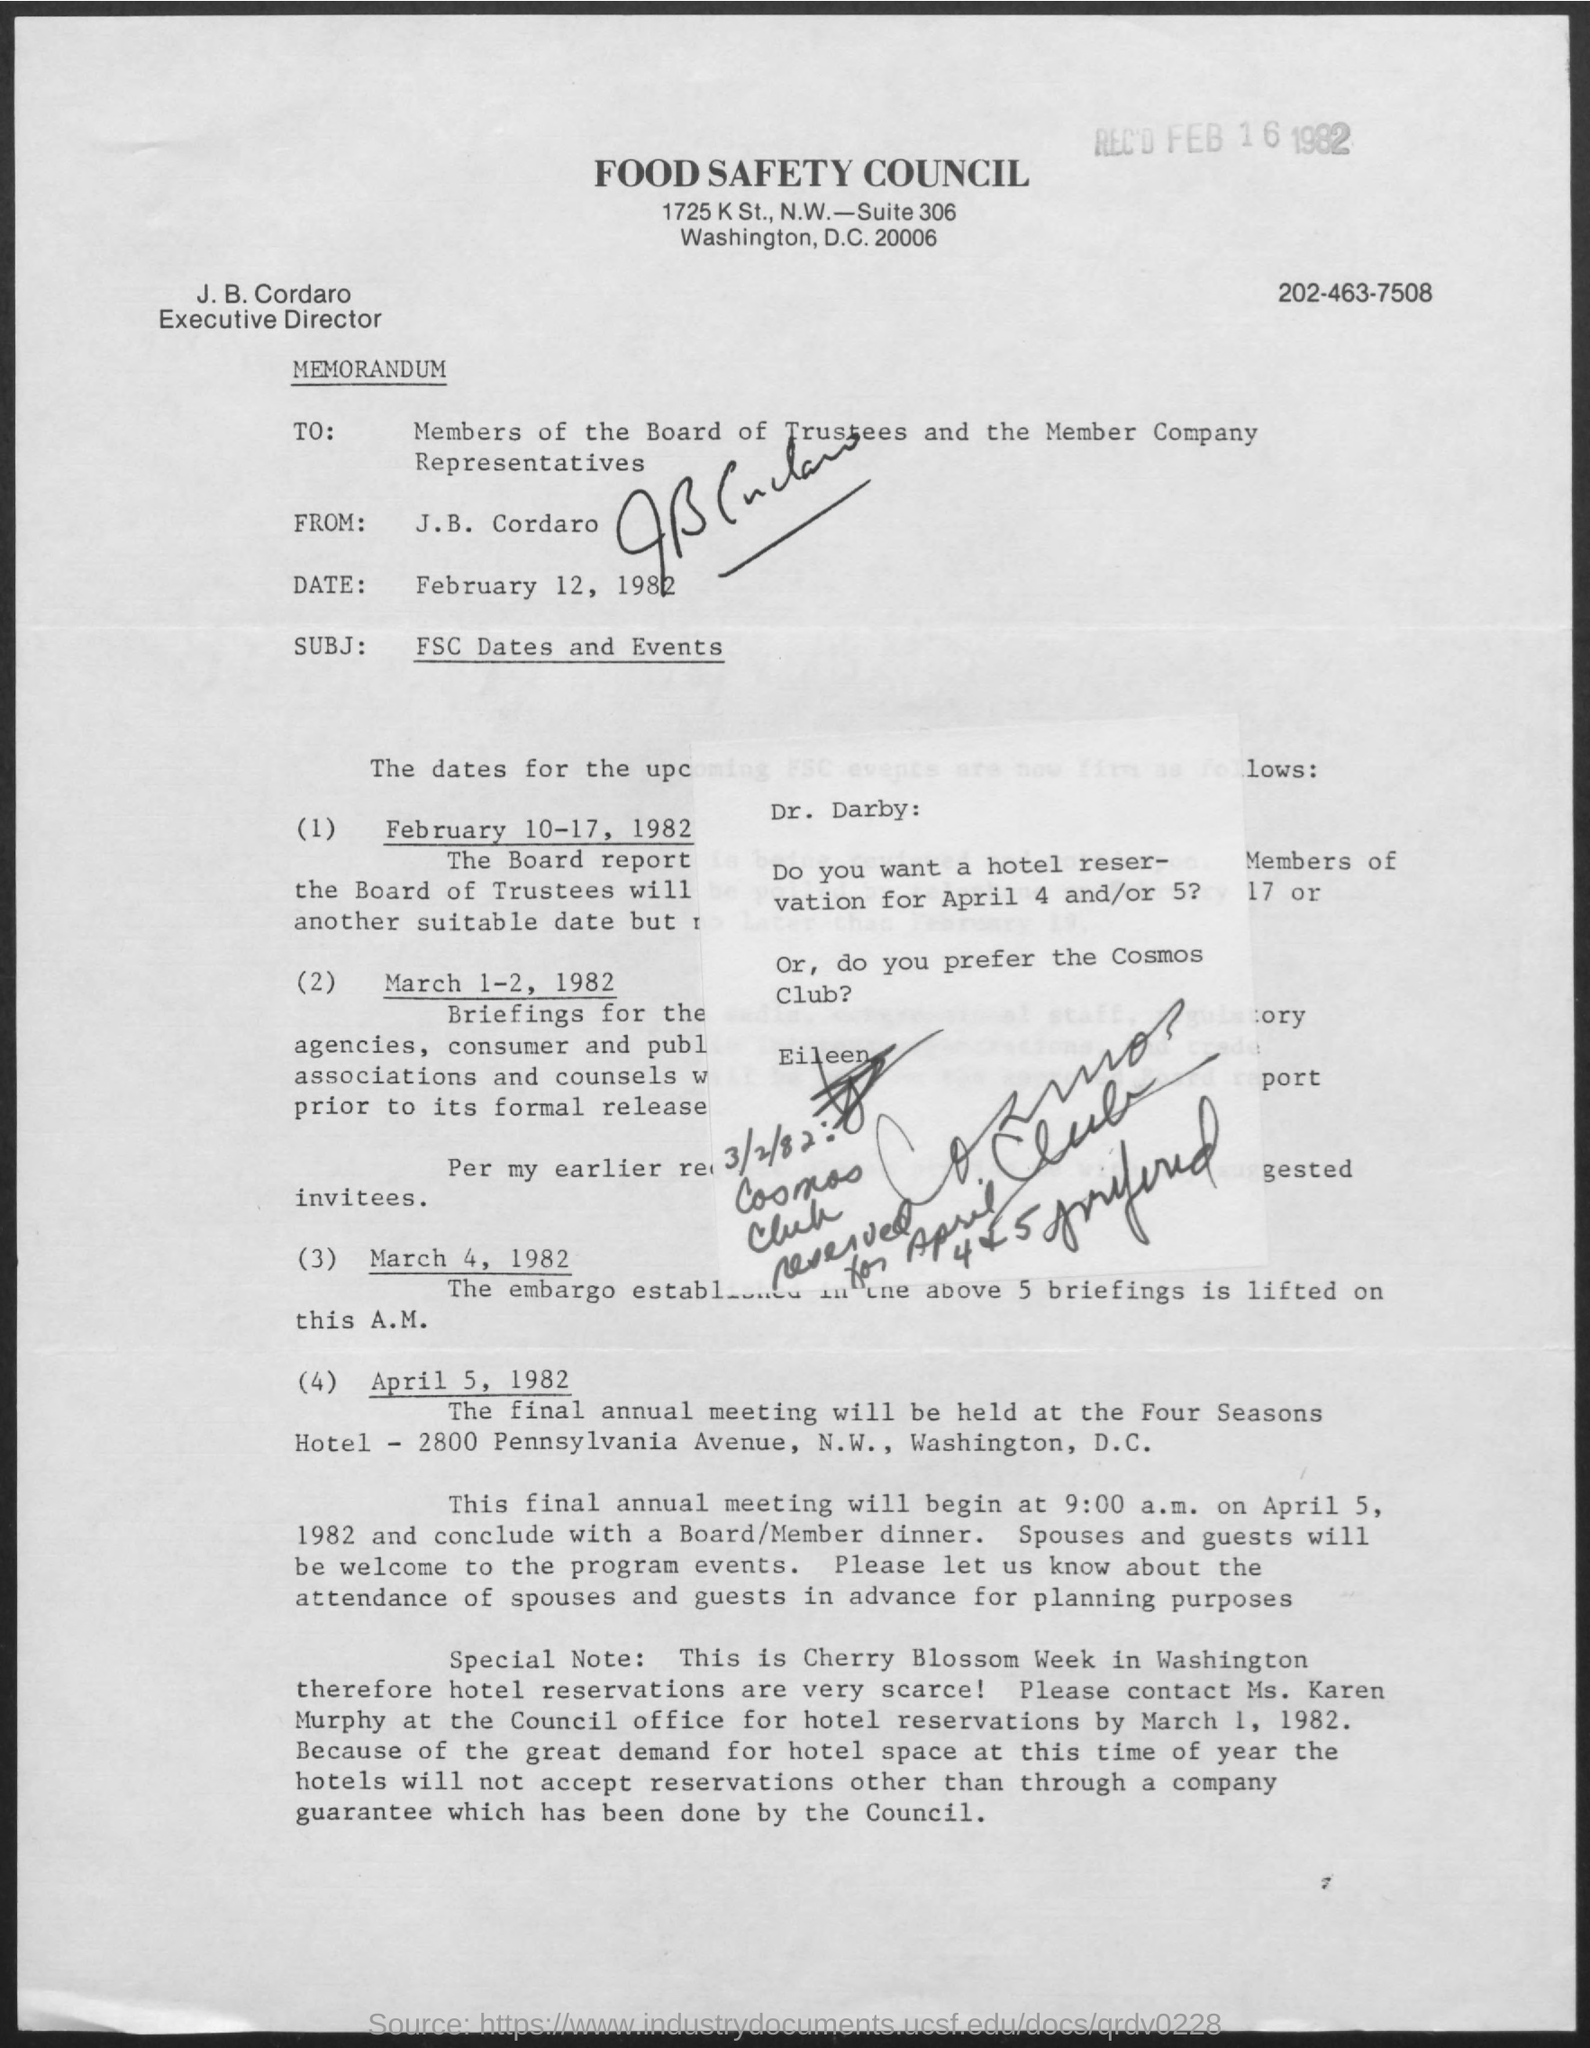What is the title of the document?
Make the answer very short. Food Safety Council. What is the full form of FSC?
Ensure brevity in your answer.  Food safety council. 